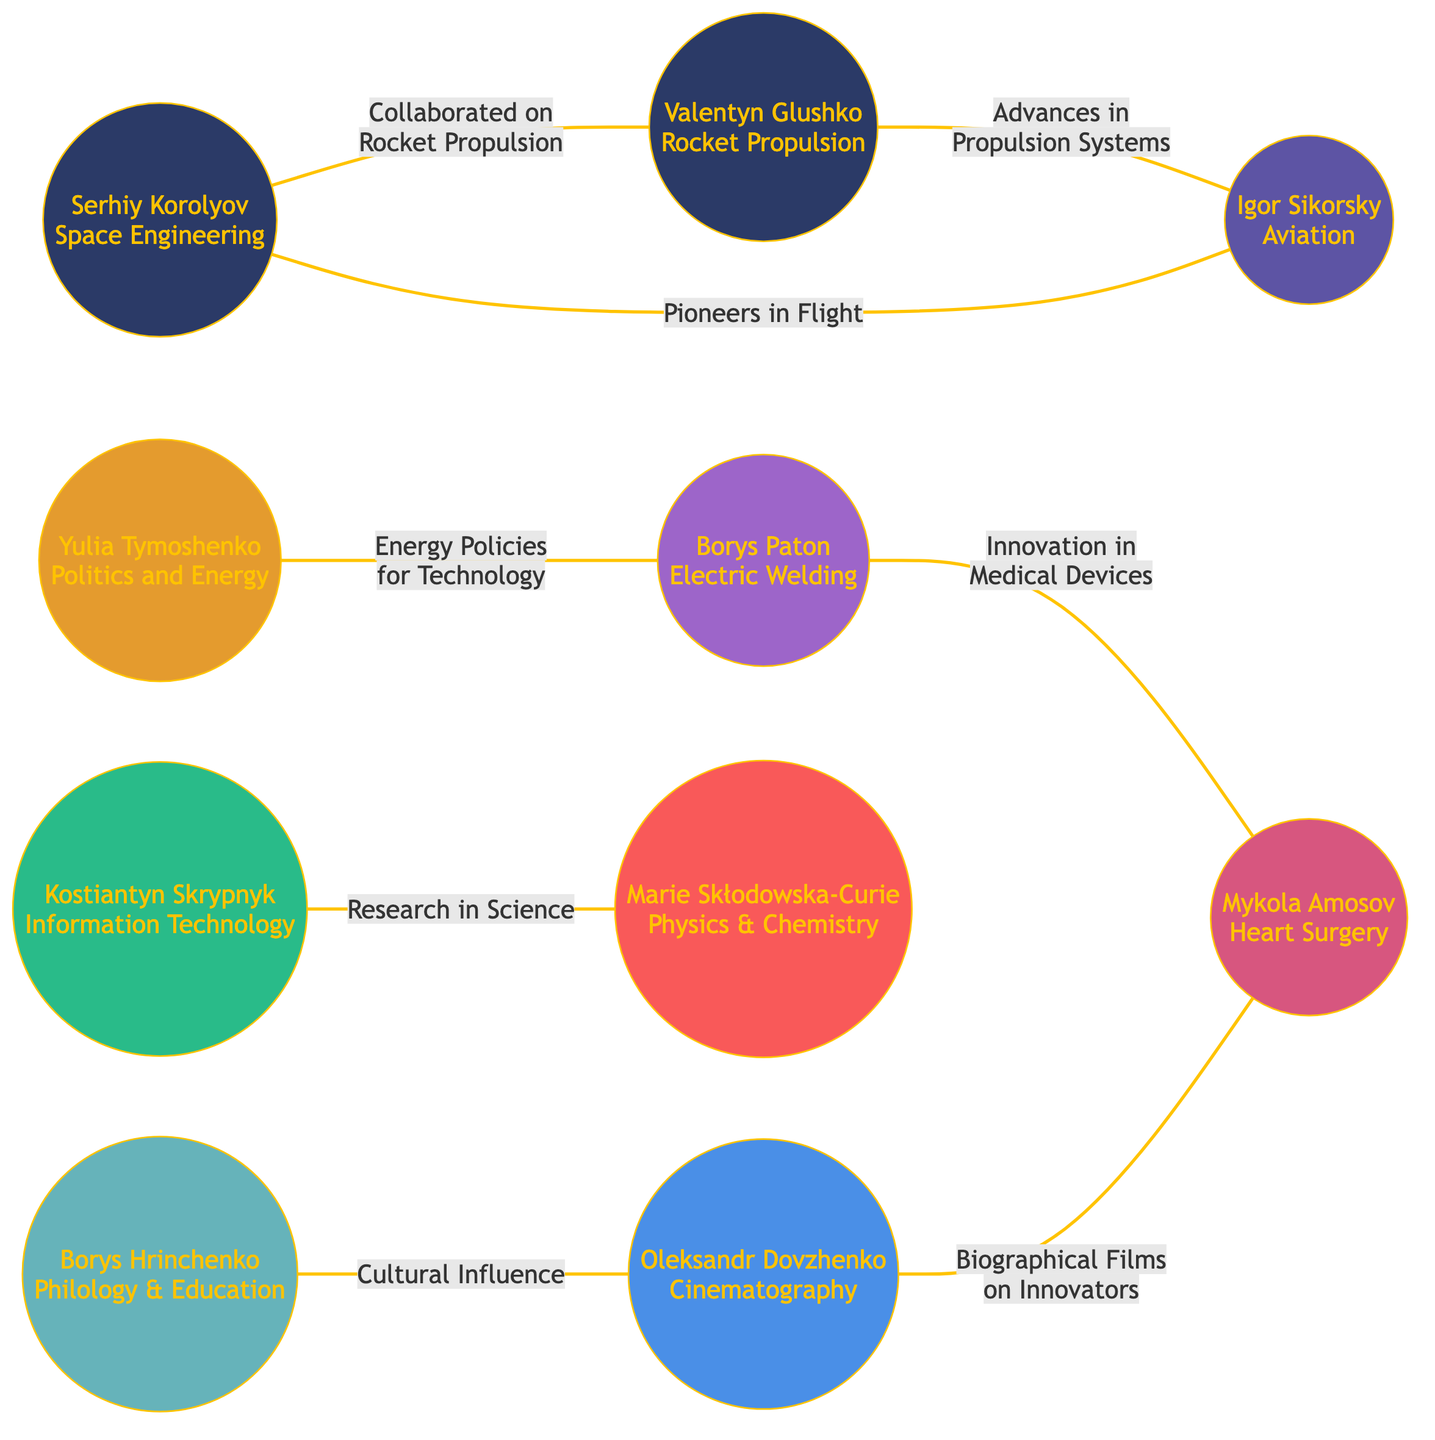What is the field of Serhiy Korolyov? The label of the node for Serhiy Korolyov indicates that his field is "Space Engineering."
Answer: Space Engineering How many nodes are present in the diagram? The data provides a list of nodes; counting the nodes, there are 10 in total listed under the "nodes."
Answer: 10 Who did Igor Sikorsky collaborate with? The edge labeled "Pioneers in Flight" connects Igor Sikorsky directly to Serhiy Korolyov, indicating their collaboration.
Answer: Serhiy Korolyov What is the connection between Borys Paton and Mykola Amosov? The edge between Borys Paton and Mykola Amosov is labeled "Innovation in Medical Devices," which describes their relationship.
Answer: Innovation in Medical Devices Which two innovators are related through cultural influence? The edge connecting Borys Hrinchenko and Oleksandr Dovzhenko indicates "Cultural Influence," showing their relationship.
Answer: Borys Hrinchenko and Oleksandr Dovzhenko How many edges are in the diagram? The edges are the connections between nodes; by counting the edges listed, there are 8 in total.
Answer: 8 Who is associated with advances in propulsion systems? The edge from Valentyn Glushko to Igor Sikorsky indicates the label "Advances in Propulsion Systems," linking them in this field.
Answer: Igor Sikorsky Which two fields are connected through research in science? The edge labeled "Research in Science" connects Kostiantyn Skrypnyk and Marie Skłodowska-Curie, indicating their relationship in those fields.
Answer: Kostiantyn Skrypnyk and Marie Skłodowska-Curie What type of influence did Oleksandr Dovzhenko have on Mykola Amosov? The connection between Oleksandr Dovzhenko and Mykola Amosov, labeled "Biographical Films on Innovators," describes the type of influence.
Answer: Biographical Films on Innovators Which field does Yulia Tymoshenko belong to? According to the label on the node, Yulia Tymoshenko's field is described as "Politics and Energy."
Answer: Politics and Energy 